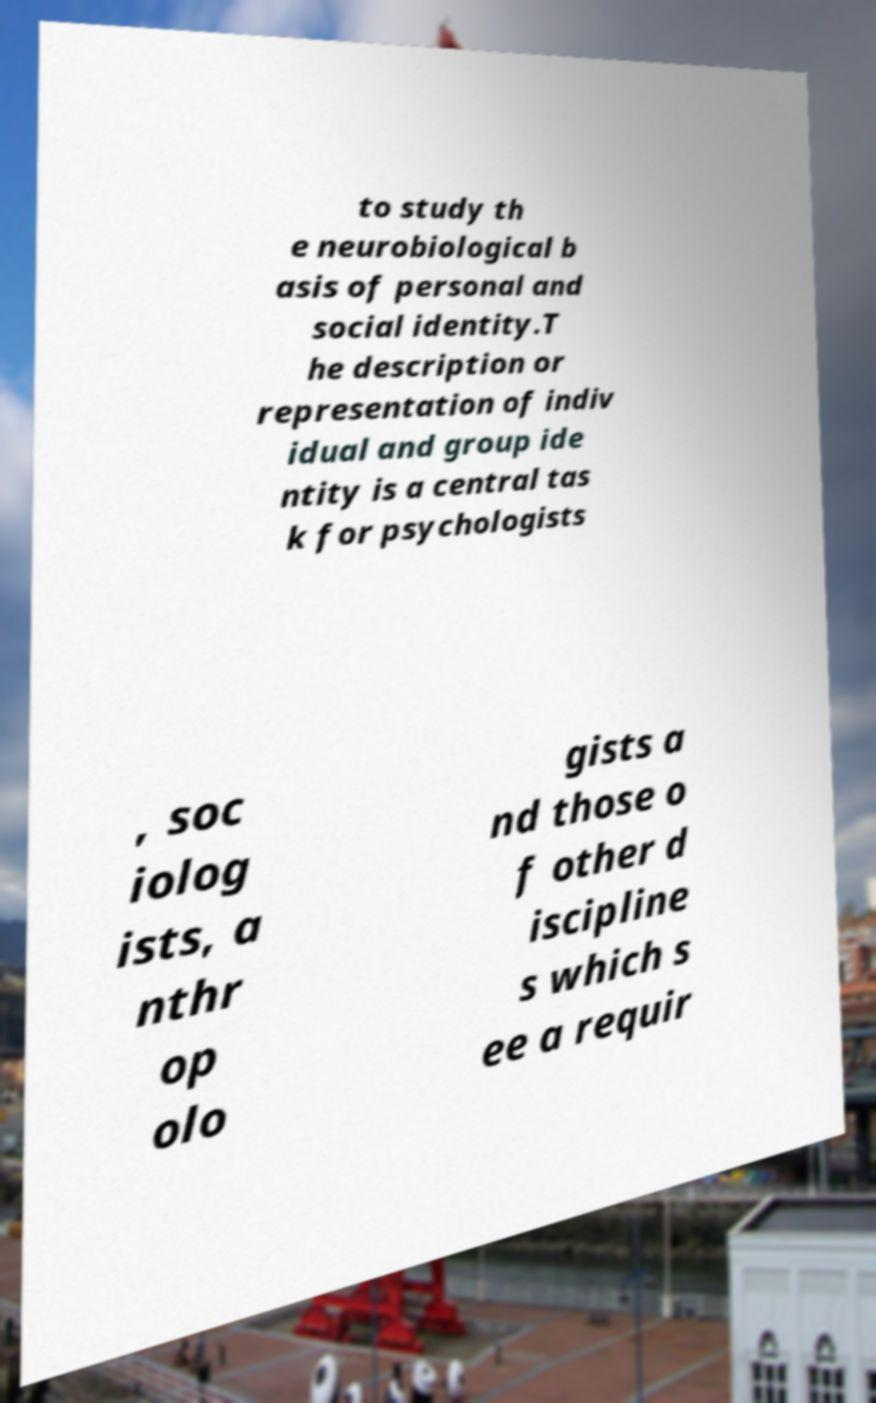What messages or text are displayed in this image? I need them in a readable, typed format. to study th e neurobiological b asis of personal and social identity.T he description or representation of indiv idual and group ide ntity is a central tas k for psychologists , soc iolog ists, a nthr op olo gists a nd those o f other d iscipline s which s ee a requir 